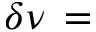Convert formula to latex. <formula><loc_0><loc_0><loc_500><loc_500>\delta \nu \, =</formula> 